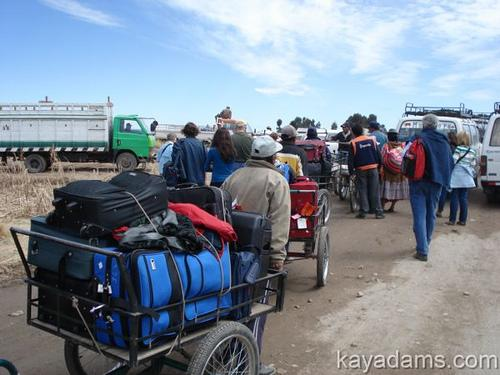Summarize the main scene in the image in one sentence. A bustling street scene features a man struggling to pull a cart loaded with luggage, amid people and vehicles on a murrum road. In one sentence, explain the most noticeable event in the image. A beige-jacketed man pulls a cart with various bags, including a blue suitcase, along a bustling dirt road with people and vehicles. Describe the prominent activity happening in the picture. A man on a murrum road struggles to pull a cart filled with luggage, including a blue suitcase, as people and vehicles crowd the path. Provide a short, descriptive sentence about the picture's main action. A man pulls a luggage-filled cart on a crowded dirt road, with a blue suitcase among the items, as people and vehicles pass nearby. Create a brief, descriptive sentence focused on the primary occurrence in the image. A man in a beige jacket is manoeuvring a luggage-loaded cart across a busy, dirt road filled with people, cars, and a green and white truck. Write a short description of the main focus in the image. A man pulls a cart full of luggage, including a blue suitcase, along a busy street with people and vehicles on a dirt road. Write a brief overview of the image's content, focusing on the main scenario. People and vehicles occupy a busy dirt street, while a man in a beige jacket pulls a cart full of luggage, and a couple in blue shirts walks by. Briefly illustrate the overall scene captured in the image. People are gathered on a murrum road with vehicles, while a man in a beige jacket pulls a cart filled with luggage, and the sky has fluffy white clouds. Mention the key object in the image and its surroundings. A cart carrying bags, surrounded by people on a bustling dirt road with vehicles, as a man wearing a blue shirt carries a red backpack. Compose a simple sentence describing the image's central subject. A man wearing a beige jacket is pulling a cart loaded with luggage on a busy dirt street. 